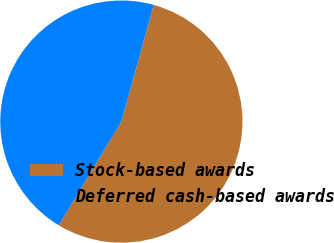<chart> <loc_0><loc_0><loc_500><loc_500><pie_chart><fcel>Stock-based awards<fcel>Deferred cash-based awards<nl><fcel>54.34%<fcel>45.66%<nl></chart> 